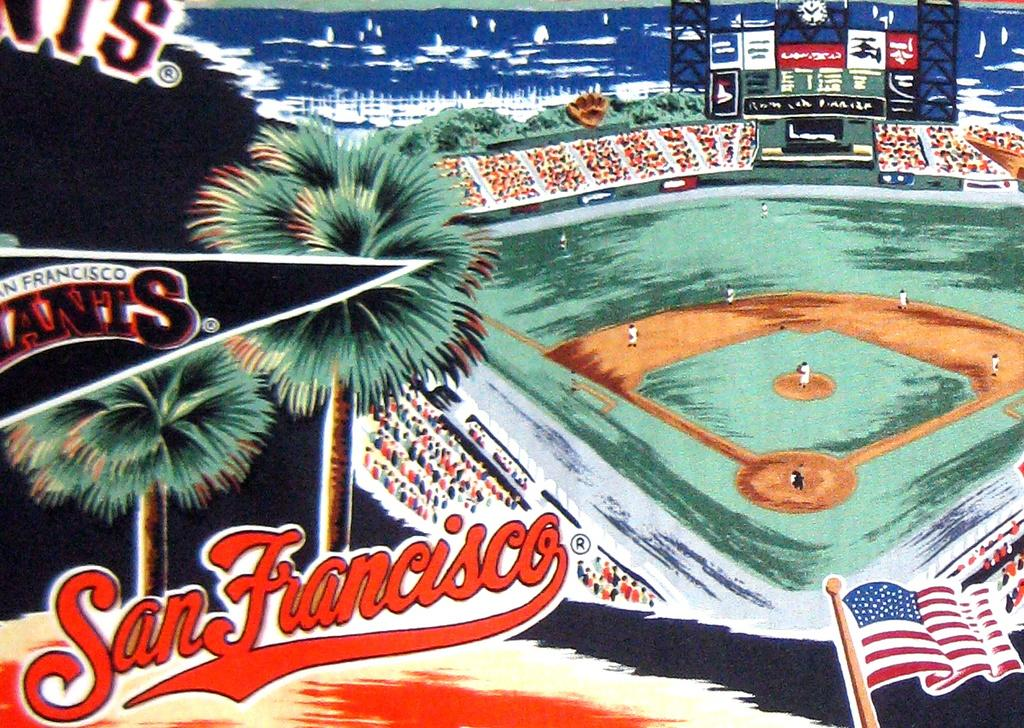<image>
Render a clear and concise summary of the photo. A San Francisco Giants baseball field with players on the field. 